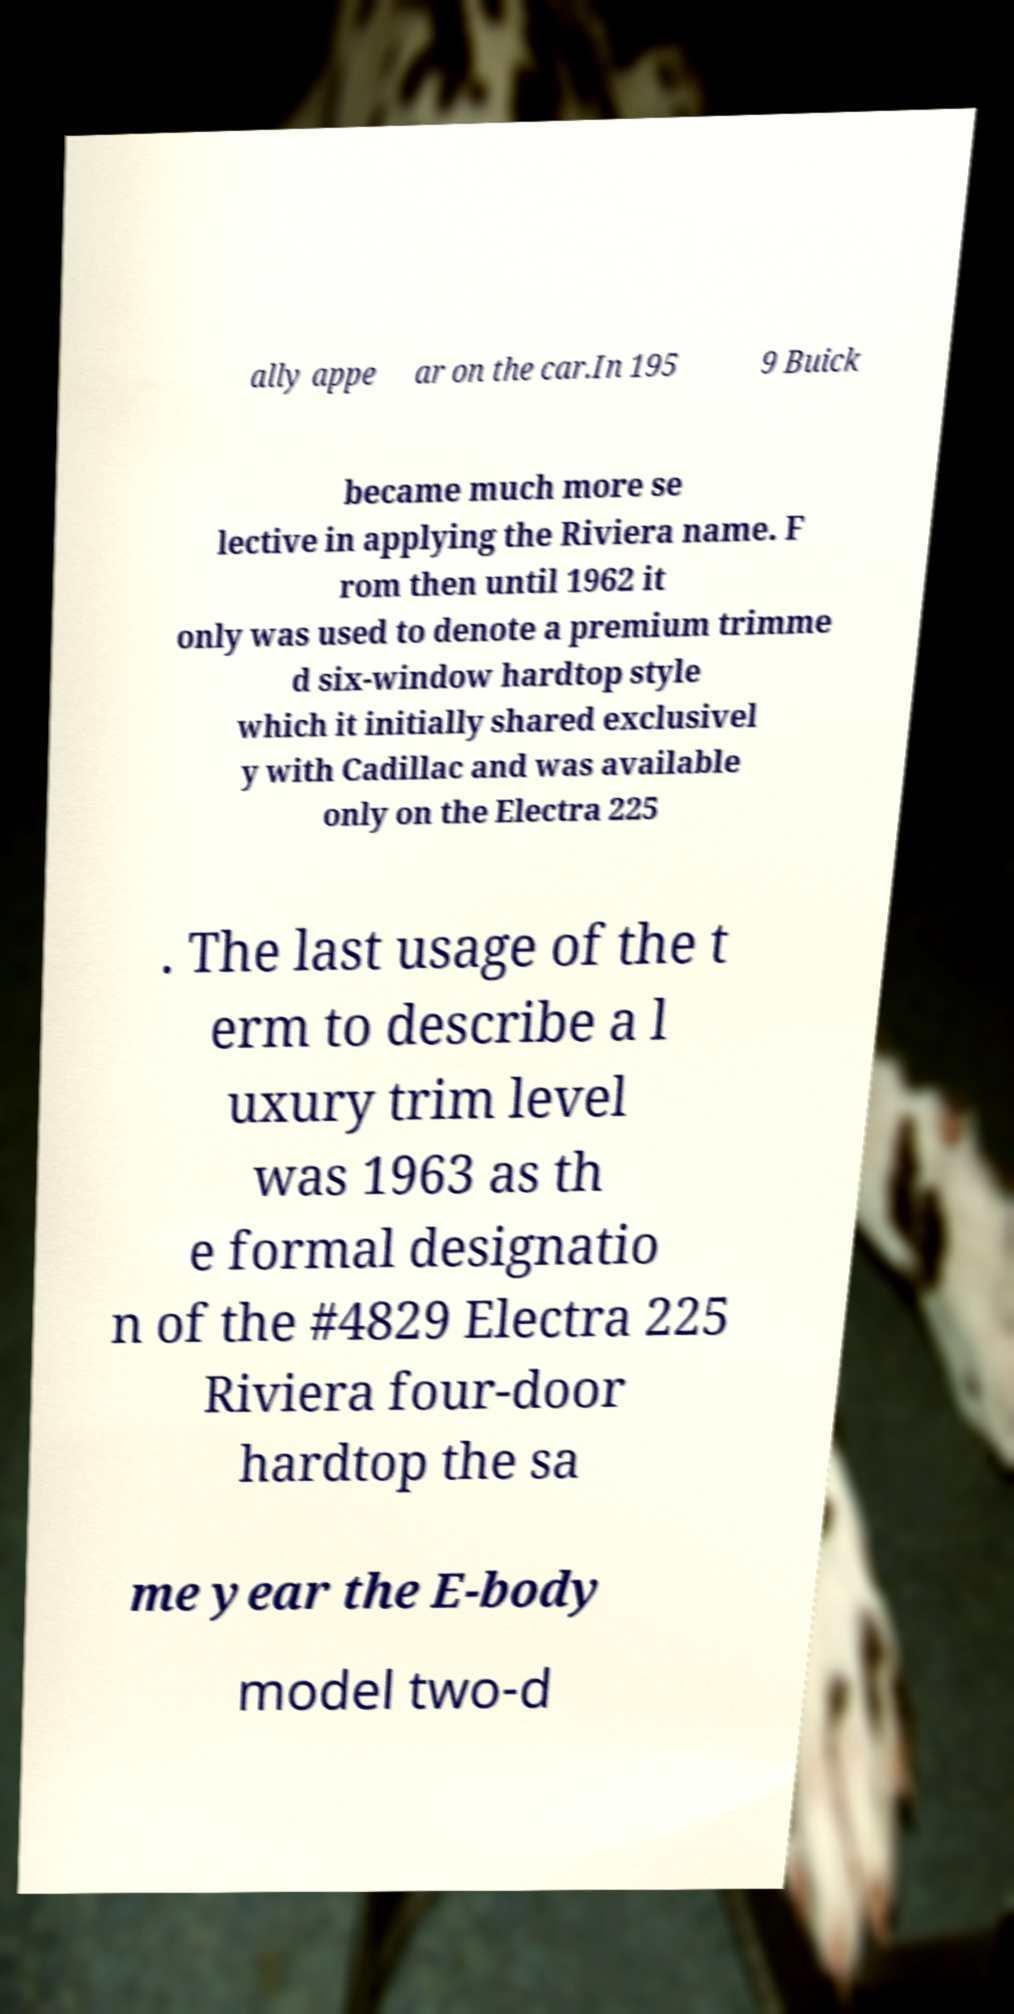Please read and relay the text visible in this image. What does it say? ally appe ar on the car.In 195 9 Buick became much more se lective in applying the Riviera name. F rom then until 1962 it only was used to denote a premium trimme d six-window hardtop style which it initially shared exclusivel y with Cadillac and was available only on the Electra 225 . The last usage of the t erm to describe a l uxury trim level was 1963 as th e formal designatio n of the #4829 Electra 225 Riviera four-door hardtop the sa me year the E-body model two-d 